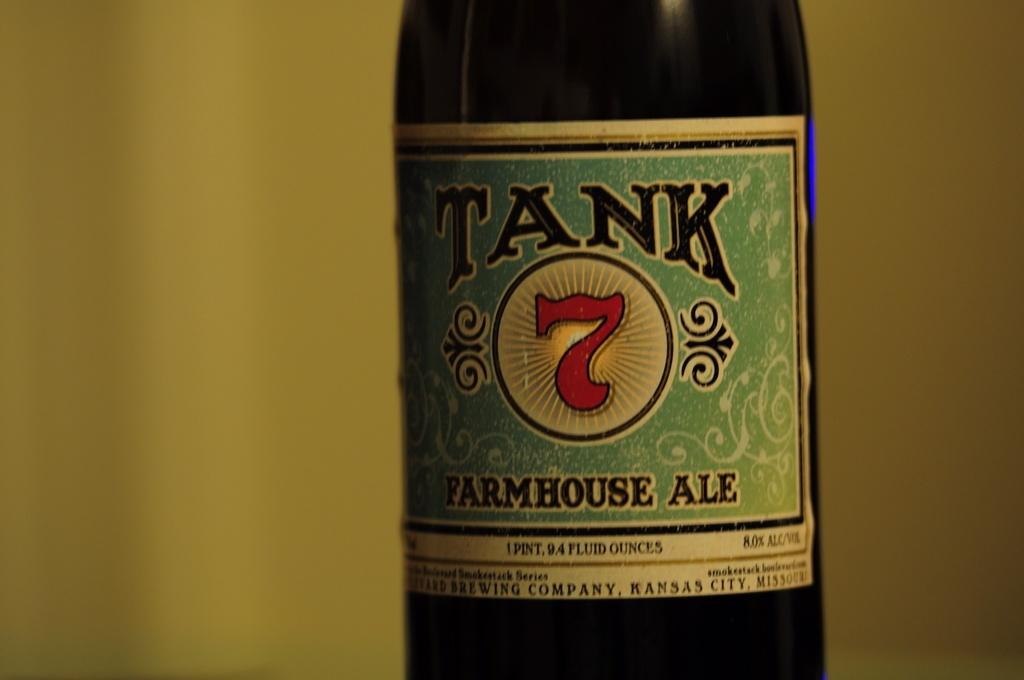<image>
Write a terse but informative summary of the picture. A bottle of Tank farmhouse ale on a blue label. 